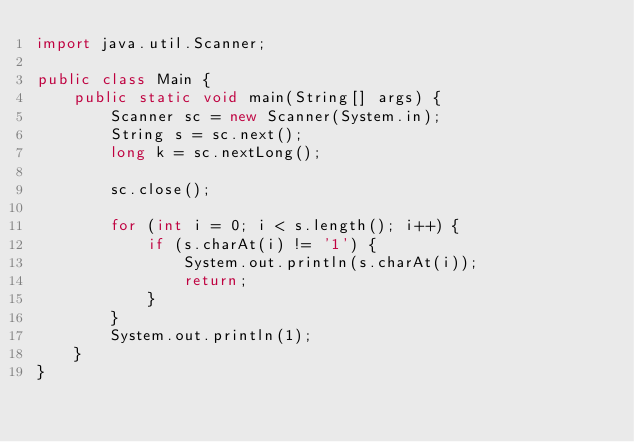<code> <loc_0><loc_0><loc_500><loc_500><_Java_>import java.util.Scanner;

public class Main {
    public static void main(String[] args) {
        Scanner sc = new Scanner(System.in);
        String s = sc.next();
        long k = sc.nextLong();

        sc.close();

        for (int i = 0; i < s.length(); i++) {
            if (s.charAt(i) != '1') {
                System.out.println(s.charAt(i));
                return;
            }
        }
        System.out.println(1);
    }
}</code> 